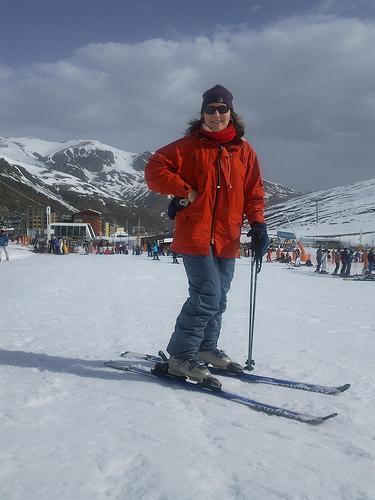How many people are pictured?
Give a very brief answer. 1. How many skis do you see?
Give a very brief answer. 2. 